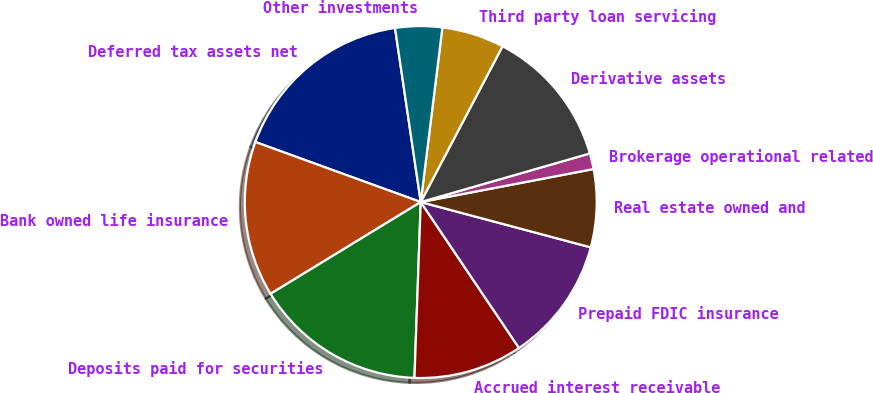Convert chart to OTSL. <chart><loc_0><loc_0><loc_500><loc_500><pie_chart><fcel>Deferred tax assets net<fcel>Bank owned life insurance<fcel>Deposits paid for securities<fcel>Accrued interest receivable<fcel>Prepaid FDIC insurance<fcel>Real estate owned and<fcel>Brokerage operational related<fcel>Derivative assets<fcel>Third party loan servicing<fcel>Other investments<nl><fcel>17.12%<fcel>14.27%<fcel>15.7%<fcel>10.0%<fcel>11.42%<fcel>7.15%<fcel>1.45%<fcel>12.85%<fcel>5.73%<fcel>4.3%<nl></chart> 